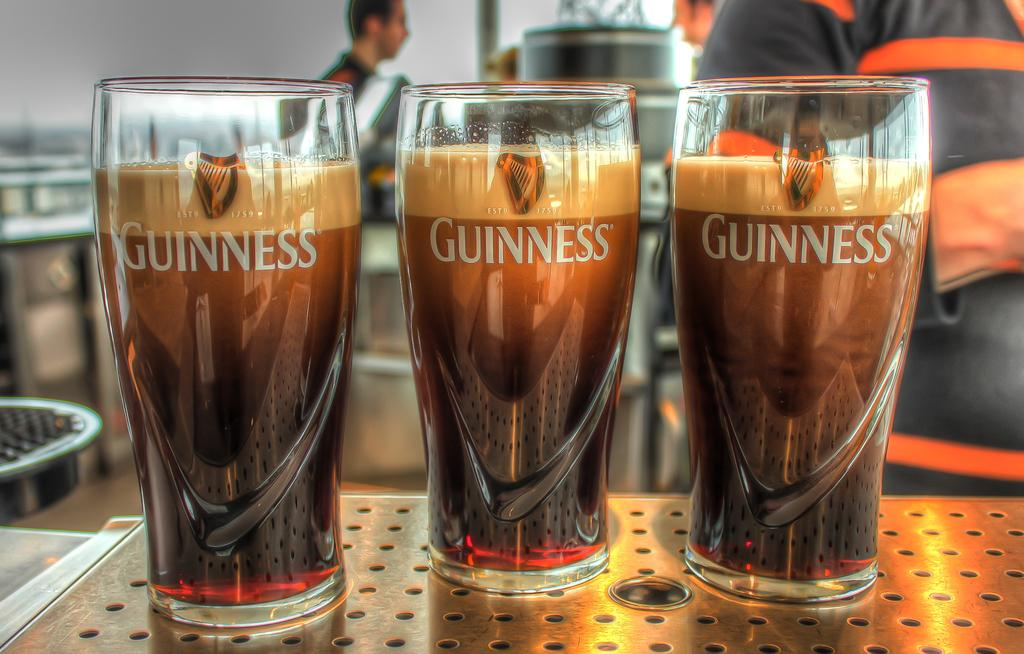<image>
Describe the image concisely. Three tall drinking glasses, with the word Guiness on each, filled with some type of beverage. 